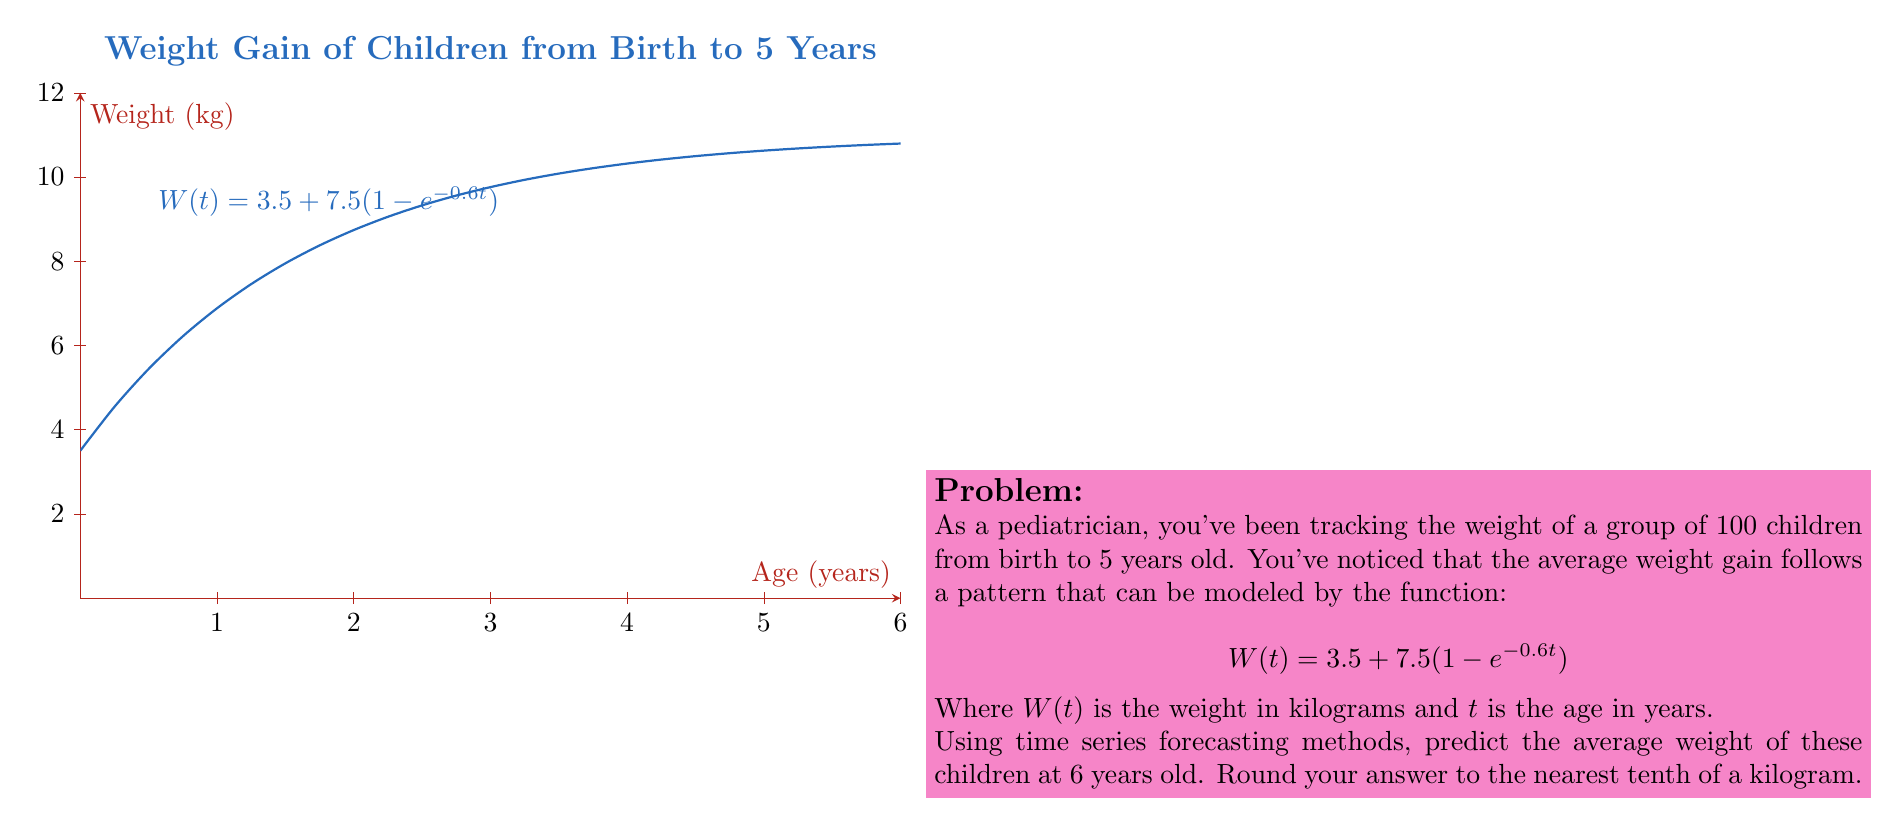Give your solution to this math problem. To predict the average weight at 6 years old, we need to evaluate the given function $W(t)$ at $t = 6$. Let's break this down step-by-step:

1) The given function is:
   $$W(t) = 3.5 + 7.5(1 - e^{-0.6t})$$

2) We need to calculate $W(6)$:
   $$W(6) = 3.5 + 7.5(1 - e^{-0.6(6)})$$

3) Let's evaluate the exponent first:
   $$-0.6(6) = -3.6$$

4) Now, let's calculate $e^{-3.6}$:
   $$e^{-3.6} \approx 0.0273$$

5) Substitute this back into our equation:
   $$W(6) = 3.5 + 7.5(1 - 0.0273)$$
   $$W(6) = 3.5 + 7.5(0.9727)$$

6) Multiply:
   $$W(6) = 3.5 + 7.2953$$

7) Add:
   $$W(6) = 10.7953$$

8) Rounding to the nearest tenth:
   $$W(6) \approx 10.8$$

Therefore, the predicted average weight of the children at 6 years old is approximately 10.8 kg.
Answer: 10.8 kg 